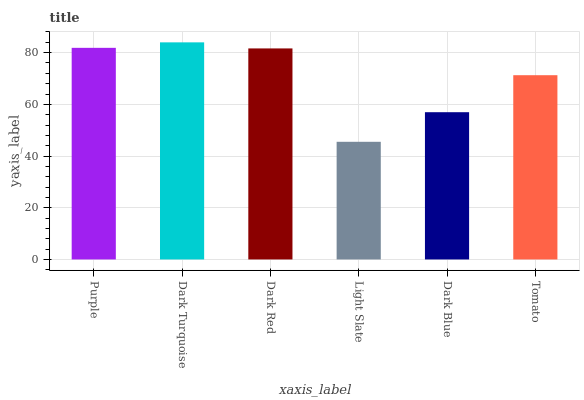Is Light Slate the minimum?
Answer yes or no. Yes. Is Dark Turquoise the maximum?
Answer yes or no. Yes. Is Dark Red the minimum?
Answer yes or no. No. Is Dark Red the maximum?
Answer yes or no. No. Is Dark Turquoise greater than Dark Red?
Answer yes or no. Yes. Is Dark Red less than Dark Turquoise?
Answer yes or no. Yes. Is Dark Red greater than Dark Turquoise?
Answer yes or no. No. Is Dark Turquoise less than Dark Red?
Answer yes or no. No. Is Dark Red the high median?
Answer yes or no. Yes. Is Tomato the low median?
Answer yes or no. Yes. Is Light Slate the high median?
Answer yes or no. No. Is Dark Turquoise the low median?
Answer yes or no. No. 